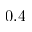Convert formula to latex. <formula><loc_0><loc_0><loc_500><loc_500>- 0 . 4</formula> 